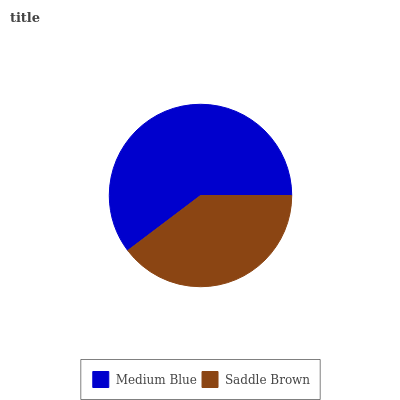Is Saddle Brown the minimum?
Answer yes or no. Yes. Is Medium Blue the maximum?
Answer yes or no. Yes. Is Saddle Brown the maximum?
Answer yes or no. No. Is Medium Blue greater than Saddle Brown?
Answer yes or no. Yes. Is Saddle Brown less than Medium Blue?
Answer yes or no. Yes. Is Saddle Brown greater than Medium Blue?
Answer yes or no. No. Is Medium Blue less than Saddle Brown?
Answer yes or no. No. Is Medium Blue the high median?
Answer yes or no. Yes. Is Saddle Brown the low median?
Answer yes or no. Yes. Is Saddle Brown the high median?
Answer yes or no. No. Is Medium Blue the low median?
Answer yes or no. No. 